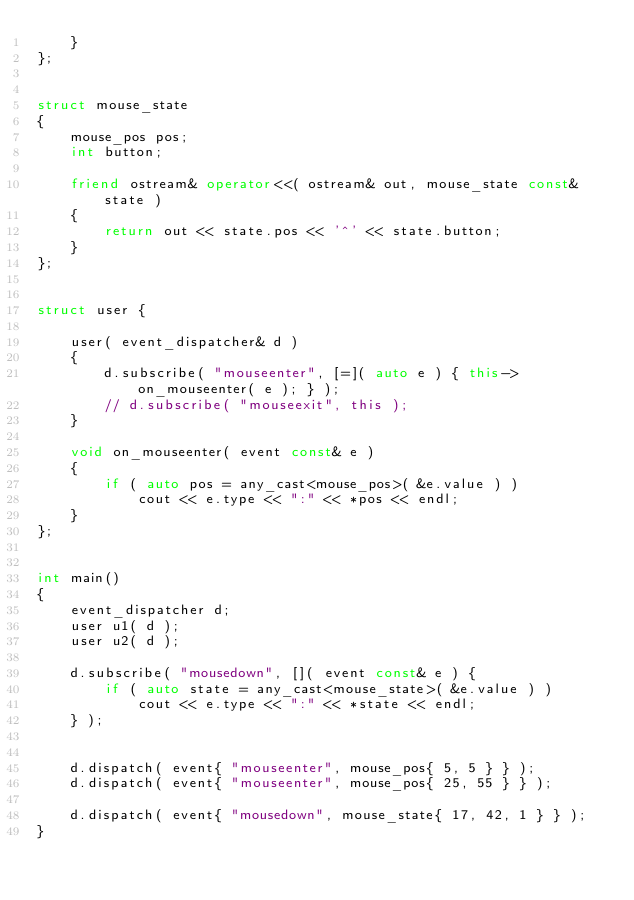Convert code to text. <code><loc_0><loc_0><loc_500><loc_500><_C++_>    }
};


struct mouse_state
{
    mouse_pos pos;
    int button;

    friend ostream& operator<<( ostream& out, mouse_state const& state )
    {
        return out << state.pos << '^' << state.button;
    }
};


struct user {

    user( event_dispatcher& d )
    {
        d.subscribe( "mouseenter", [=]( auto e ) { this->on_mouseenter( e ); } );
        // d.subscribe( "mouseexit", this );
    }

    void on_mouseenter( event const& e )
    {
        if ( auto pos = any_cast<mouse_pos>( &e.value ) )
            cout << e.type << ":" << *pos << endl;
    }
};


int main()
{
    event_dispatcher d;
    user u1( d );
    user u2( d );

    d.subscribe( "mousedown", []( event const& e ) {
        if ( auto state = any_cast<mouse_state>( &e.value ) )
            cout << e.type << ":" << *state << endl;
    } );


    d.dispatch( event{ "mouseenter", mouse_pos{ 5, 5 } } );
    d.dispatch( event{ "mouseenter", mouse_pos{ 25, 55 } } );

    d.dispatch( event{ "mousedown", mouse_state{ 17, 42, 1 } } );
}
</code> 